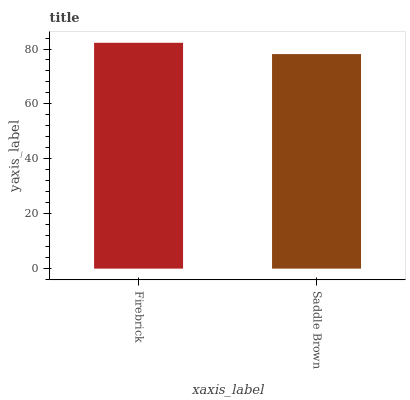Is Saddle Brown the minimum?
Answer yes or no. Yes. Is Firebrick the maximum?
Answer yes or no. Yes. Is Saddle Brown the maximum?
Answer yes or no. No. Is Firebrick greater than Saddle Brown?
Answer yes or no. Yes. Is Saddle Brown less than Firebrick?
Answer yes or no. Yes. Is Saddle Brown greater than Firebrick?
Answer yes or no. No. Is Firebrick less than Saddle Brown?
Answer yes or no. No. Is Firebrick the high median?
Answer yes or no. Yes. Is Saddle Brown the low median?
Answer yes or no. Yes. Is Saddle Brown the high median?
Answer yes or no. No. Is Firebrick the low median?
Answer yes or no. No. 